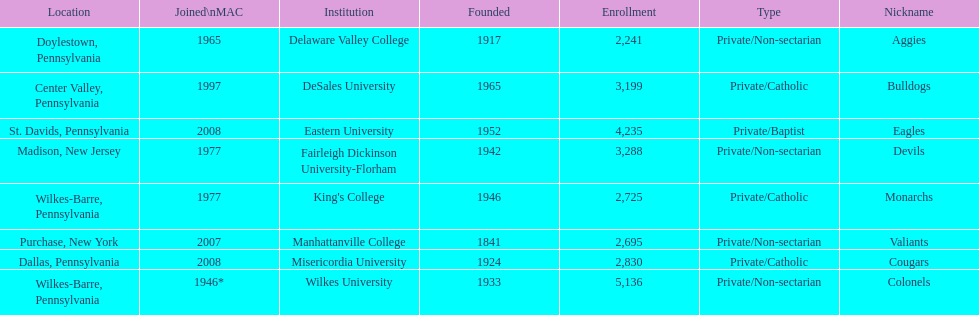Write the full table. {'header': ['Location', 'Joined\\nMAC', 'Institution', 'Founded', 'Enrollment', 'Type', 'Nickname'], 'rows': [['Doylestown, Pennsylvania', '1965', 'Delaware Valley College', '1917', '2,241', 'Private/Non-sectarian', 'Aggies'], ['Center Valley, Pennsylvania', '1997', 'DeSales University', '1965', '3,199', 'Private/Catholic', 'Bulldogs'], ['St. Davids, Pennsylvania', '2008', 'Eastern University', '1952', '4,235', 'Private/Baptist', 'Eagles'], ['Madison, New Jersey', '1977', 'Fairleigh Dickinson University-Florham', '1942', '3,288', 'Private/Non-sectarian', 'Devils'], ['Wilkes-Barre, Pennsylvania', '1977', "King's College", '1946', '2,725', 'Private/Catholic', 'Monarchs'], ['Purchase, New York', '2007', 'Manhattanville College', '1841', '2,695', 'Private/Non-sectarian', 'Valiants'], ['Dallas, Pennsylvania', '2008', 'Misericordia University', '1924', '2,830', 'Private/Catholic', 'Cougars'], ['Wilkes-Barre, Pennsylvania', '1946*', 'Wilkes University', '1933', '5,136', 'Private/Non-sectarian', 'Colonels']]} How many are enrolled in private/catholic? 8,754. 